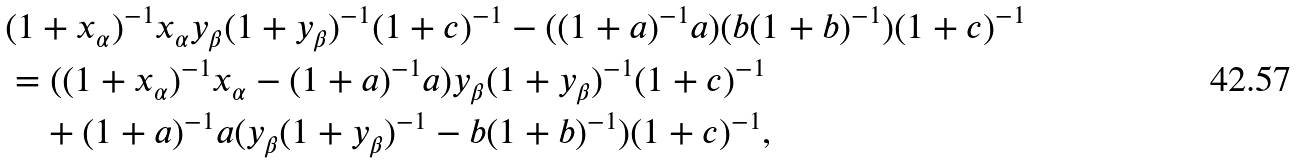Convert formula to latex. <formula><loc_0><loc_0><loc_500><loc_500>& ( 1 + x _ { \alpha } ) ^ { - 1 } x _ { \alpha } y _ { \beta } ( 1 + y _ { \beta } ) ^ { - 1 } ( 1 + c ) ^ { - 1 } - ( ( 1 + a ) ^ { - 1 } a ) ( b ( 1 + b ) ^ { - 1 } ) ( 1 + c ) ^ { - 1 } \\ & = ( ( 1 + x _ { \alpha } ) ^ { - 1 } x _ { \alpha } - ( 1 + a ) ^ { - 1 } a ) y _ { \beta } ( 1 + y _ { \beta } ) ^ { - 1 } ( 1 + c ) ^ { - 1 } \\ & \quad + ( 1 + a ) ^ { - 1 } a ( y _ { \beta } ( 1 + y _ { \beta } ) ^ { - 1 } - b ( 1 + b ) ^ { - 1 } ) ( 1 + c ) ^ { - 1 } ,</formula> 